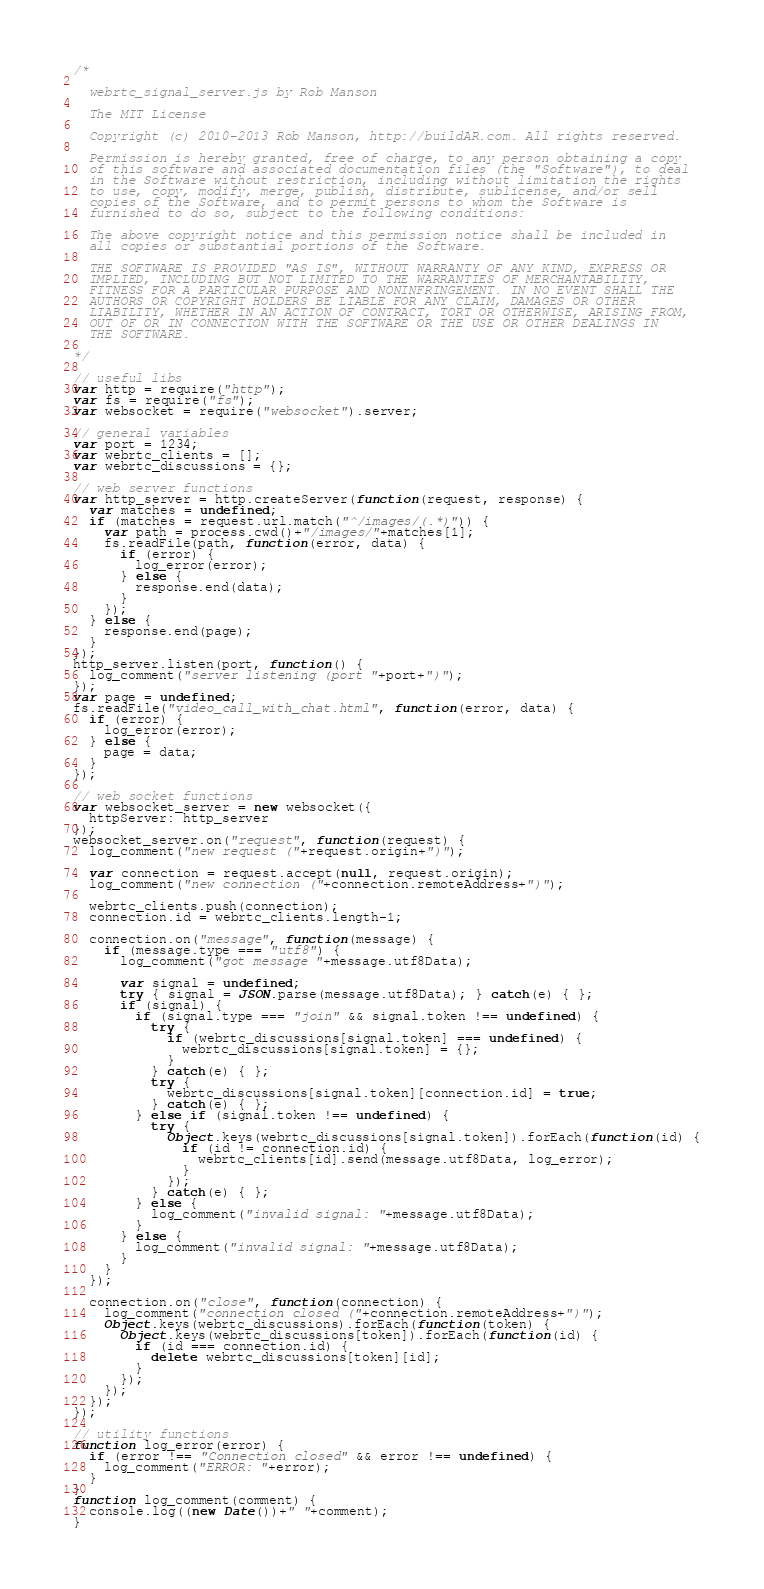Convert code to text. <code><loc_0><loc_0><loc_500><loc_500><_JavaScript_>/*

  webrtc_signal_server.js by Rob Manson

  The MIT License

  Copyright (c) 2010-2013 Rob Manson, http://buildAR.com. All rights reserved.

  Permission is hereby granted, free of charge, to any person obtaining a copy
  of this software and associated documentation files (the "Software"), to deal
  in the Software without restriction, including without limitation the rights
  to use, copy, modify, merge, publish, distribute, sublicense, and/or sell
  copies of the Software, and to permit persons to whom the Software is
  furnished to do so, subject to the following conditions:

  The above copyright notice and this permission notice shall be included in
  all copies or substantial portions of the Software.

  THE SOFTWARE IS PROVIDED "AS IS", WITHOUT WARRANTY OF ANY KIND, EXPRESS OR
  IMPLIED, INCLUDING BUT NOT LIMITED TO THE WARRANTIES OF MERCHANTABILITY,
  FITNESS FOR A PARTICULAR PURPOSE AND NONINFRINGEMENT. IN NO EVENT SHALL THE
  AUTHORS OR COPYRIGHT HOLDERS BE LIABLE FOR ANY CLAIM, DAMAGES OR OTHER
  LIABILITY, WHETHER IN AN ACTION OF CONTRACT, TORT OR OTHERWISE, ARISING FROM,
  OUT OF OR IN CONNECTION WITH THE SOFTWARE OR THE USE OR OTHER DEALINGS IN
  THE SOFTWARE.

*/

// useful libs
var http = require("http");
var fs = require("fs");
var websocket = require("websocket").server;

// general variables
var port = 1234;
var webrtc_clients = [];
var webrtc_discussions = {};

// web server functions
var http_server = http.createServer(function(request, response) {
  var matches = undefined;
  if (matches = request.url.match("^/images/(.*)")) {
    var path = process.cwd()+"/images/"+matches[1];
    fs.readFile(path, function(error, data) {
      if (error) {
        log_error(error);
      } else {
        response.end(data);
      }
    });
  } else {
    response.end(page);
  }
});
http_server.listen(port, function() {
  log_comment("server listening (port "+port+")");
});
var page = undefined;
fs.readFile("video_call_with_chat.html", function(error, data) {
  if (error) {
    log_error(error);
  } else {
    page = data;
  }
});

// web socket functions
var websocket_server = new websocket({
  httpServer: http_server
});
websocket_server.on("request", function(request) {
  log_comment("new request ("+request.origin+")");

  var connection = request.accept(null, request.origin);
  log_comment("new connection ("+connection.remoteAddress+")");

  webrtc_clients.push(connection);
  connection.id = webrtc_clients.length-1;
  
  connection.on("message", function(message) {
    if (message.type === "utf8") {
      log_comment("got message "+message.utf8Data);

      var signal = undefined;
      try { signal = JSON.parse(message.utf8Data); } catch(e) { };
      if (signal) {
        if (signal.type === "join" && signal.token !== undefined) {
          try {
            if (webrtc_discussions[signal.token] === undefined) {
              webrtc_discussions[signal.token] = {};
            }
          } catch(e) { };
          try {
            webrtc_discussions[signal.token][connection.id] = true;
          } catch(e) { };
        } else if (signal.token !== undefined) {
          try {
            Object.keys(webrtc_discussions[signal.token]).forEach(function(id) {
              if (id != connection.id) {
                webrtc_clients[id].send(message.utf8Data, log_error);
              }
            });
          } catch(e) { };
        } else {
          log_comment("invalid signal: "+message.utf8Data);
        }
      } else {
        log_comment("invalid signal: "+message.utf8Data);
      }
    }
  });
  
  connection.on("close", function(connection) {
    log_comment("connection closed ("+connection.remoteAddress+")");    
    Object.keys(webrtc_discussions).forEach(function(token) {
      Object.keys(webrtc_discussions[token]).forEach(function(id) {
        if (id === connection.id) {
          delete webrtc_discussions[token][id];
        }
      });
    });
  });
});

// utility functions
function log_error(error) {
  if (error !== "Connection closed" && error !== undefined) {
    log_comment("ERROR: "+error);
  }
}
function log_comment(comment) {
  console.log((new Date())+" "+comment);
}
</code> 